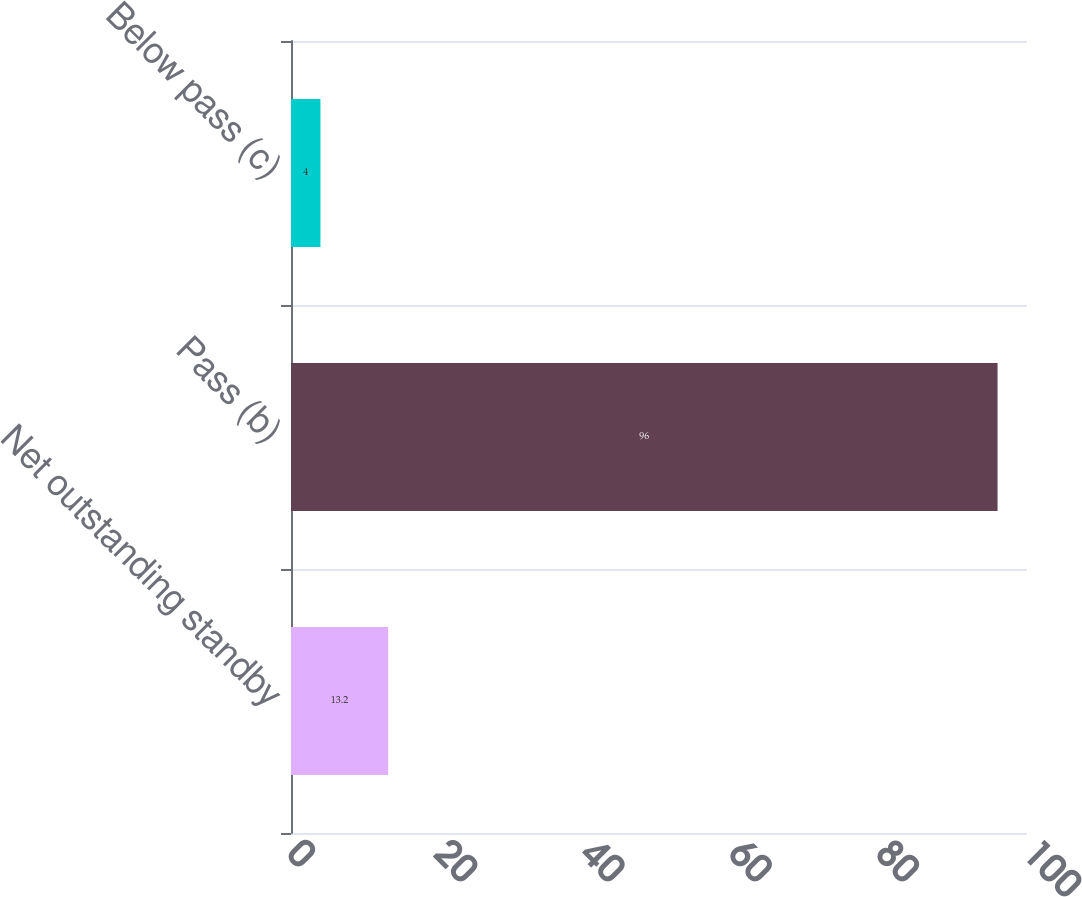Convert chart to OTSL. <chart><loc_0><loc_0><loc_500><loc_500><bar_chart><fcel>Net outstanding standby<fcel>Pass (b)<fcel>Below pass (c)<nl><fcel>13.2<fcel>96<fcel>4<nl></chart> 